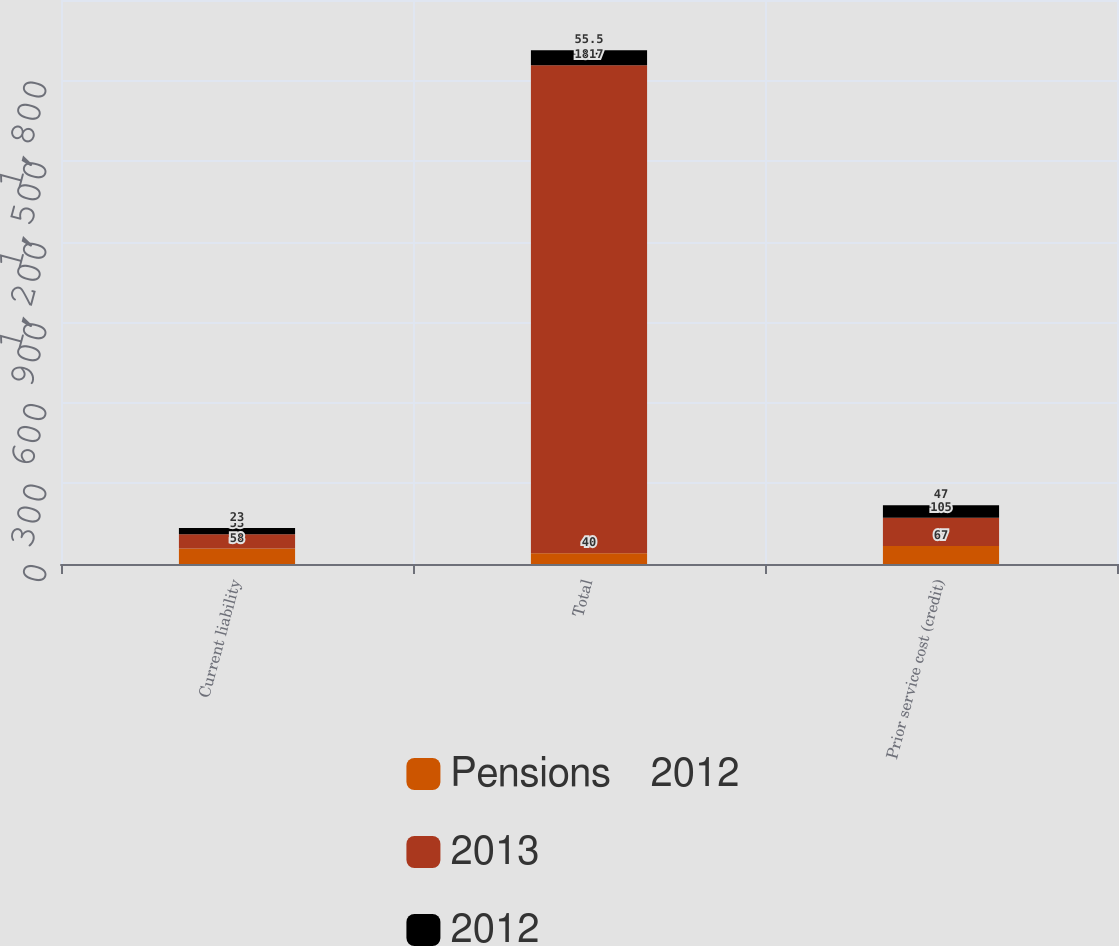Convert chart. <chart><loc_0><loc_0><loc_500><loc_500><stacked_bar_chart><ecel><fcel>Current liability<fcel>Total<fcel>Prior service cost (credit)<nl><fcel>Pensions    2012<fcel>58<fcel>40<fcel>67<nl><fcel>2013<fcel>53<fcel>1817<fcel>105<nl><fcel>2012<fcel>23<fcel>55.5<fcel>47<nl></chart> 